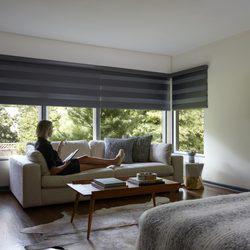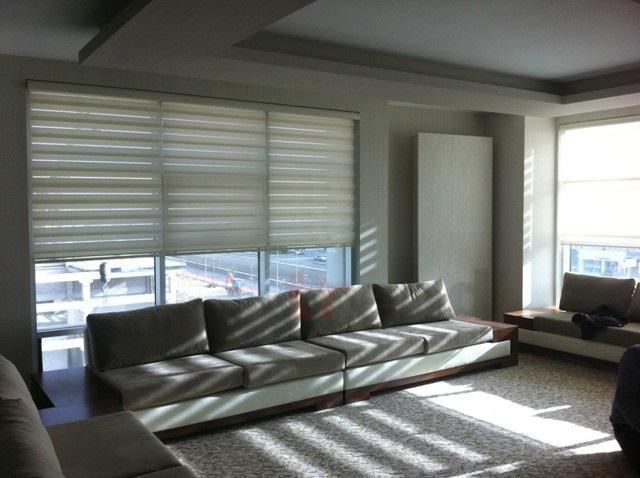The first image is the image on the left, the second image is the image on the right. For the images shown, is this caption "In at least one image there is a grey four seat sofa in front of three white open blinds." true? Answer yes or no. Yes. The first image is the image on the left, the second image is the image on the right. Evaluate the accuracy of this statement regarding the images: "The couch in the right hand image is in front of a window with sunlight coming in.". Is it true? Answer yes or no. Yes. 